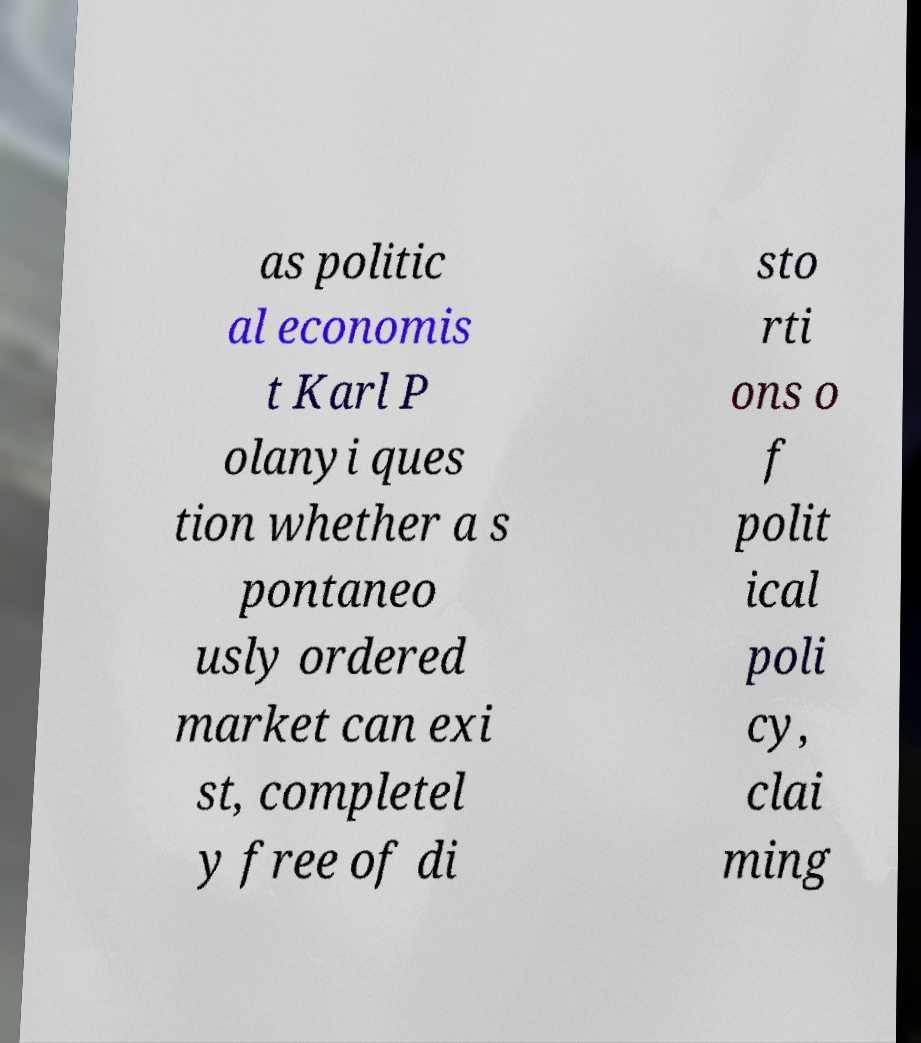Can you accurately transcribe the text from the provided image for me? as politic al economis t Karl P olanyi ques tion whether a s pontaneo usly ordered market can exi st, completel y free of di sto rti ons o f polit ical poli cy, clai ming 